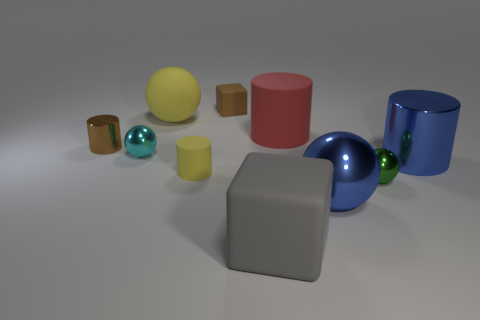Subtract 1 cylinders. How many cylinders are left? 3 Subtract all purple cylinders. Subtract all blue balls. How many cylinders are left? 4 Subtract all cylinders. How many objects are left? 6 Add 2 large brown rubber blocks. How many large brown rubber blocks exist? 2 Subtract 1 red cylinders. How many objects are left? 9 Subtract all brown shiny cylinders. Subtract all small shiny cubes. How many objects are left? 9 Add 4 red cylinders. How many red cylinders are left? 5 